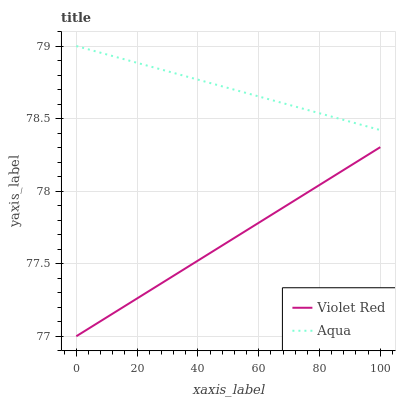Does Violet Red have the minimum area under the curve?
Answer yes or no. Yes. Does Aqua have the maximum area under the curve?
Answer yes or no. Yes. Does Aqua have the minimum area under the curve?
Answer yes or no. No. Is Violet Red the smoothest?
Answer yes or no. Yes. Is Aqua the roughest?
Answer yes or no. Yes. Is Aqua the smoothest?
Answer yes or no. No. Does Violet Red have the lowest value?
Answer yes or no. Yes. Does Aqua have the lowest value?
Answer yes or no. No. Does Aqua have the highest value?
Answer yes or no. Yes. Is Violet Red less than Aqua?
Answer yes or no. Yes. Is Aqua greater than Violet Red?
Answer yes or no. Yes. Does Violet Red intersect Aqua?
Answer yes or no. No. 